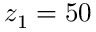Convert formula to latex. <formula><loc_0><loc_0><loc_500><loc_500>z _ { 1 } = 5 0</formula> 